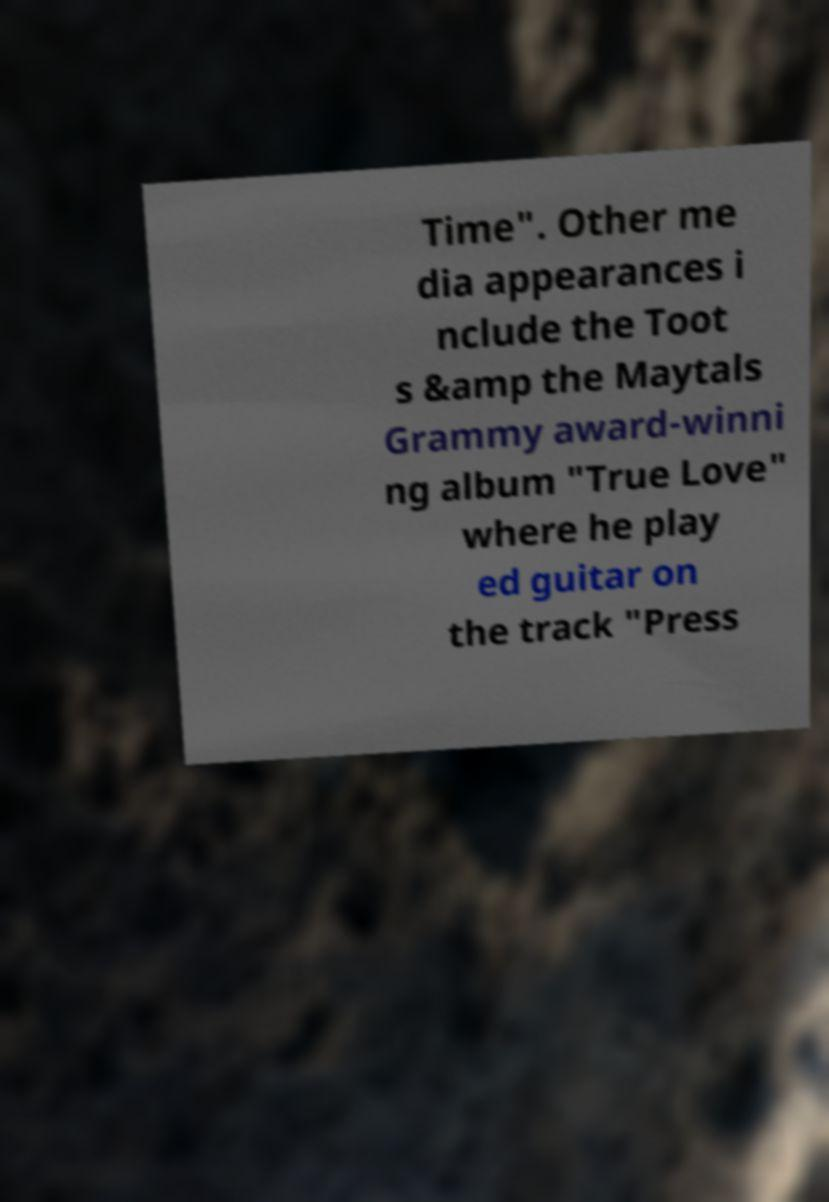I need the written content from this picture converted into text. Can you do that? Time". Other me dia appearances i nclude the Toot s &amp the Maytals Grammy award-winni ng album "True Love" where he play ed guitar on the track "Press 